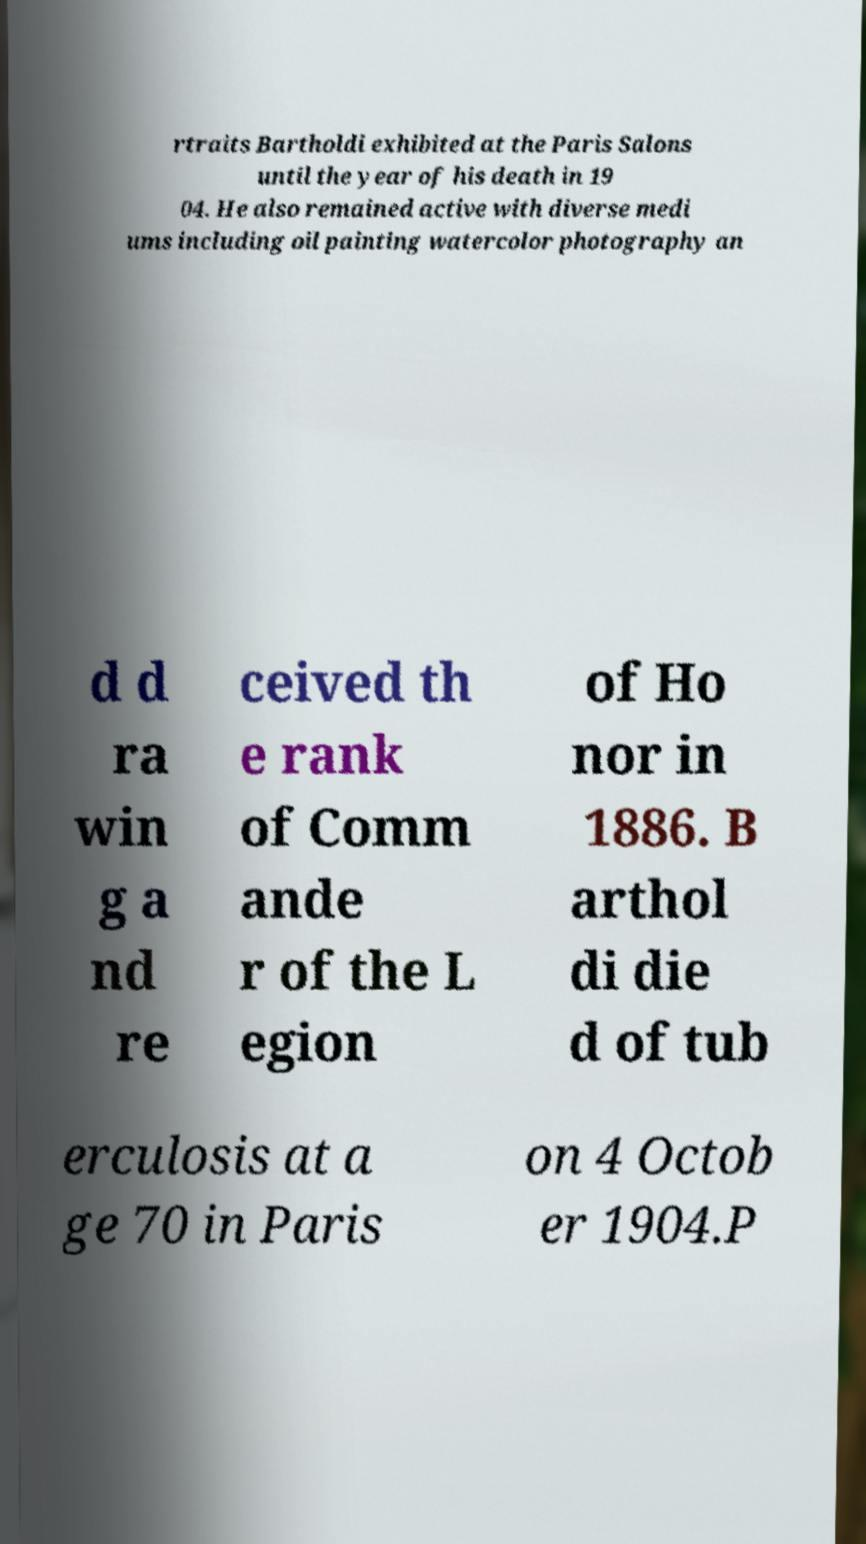Could you assist in decoding the text presented in this image and type it out clearly? rtraits Bartholdi exhibited at the Paris Salons until the year of his death in 19 04. He also remained active with diverse medi ums including oil painting watercolor photography an d d ra win g a nd re ceived th e rank of Comm ande r of the L egion of Ho nor in 1886. B arthol di die d of tub erculosis at a ge 70 in Paris on 4 Octob er 1904.P 